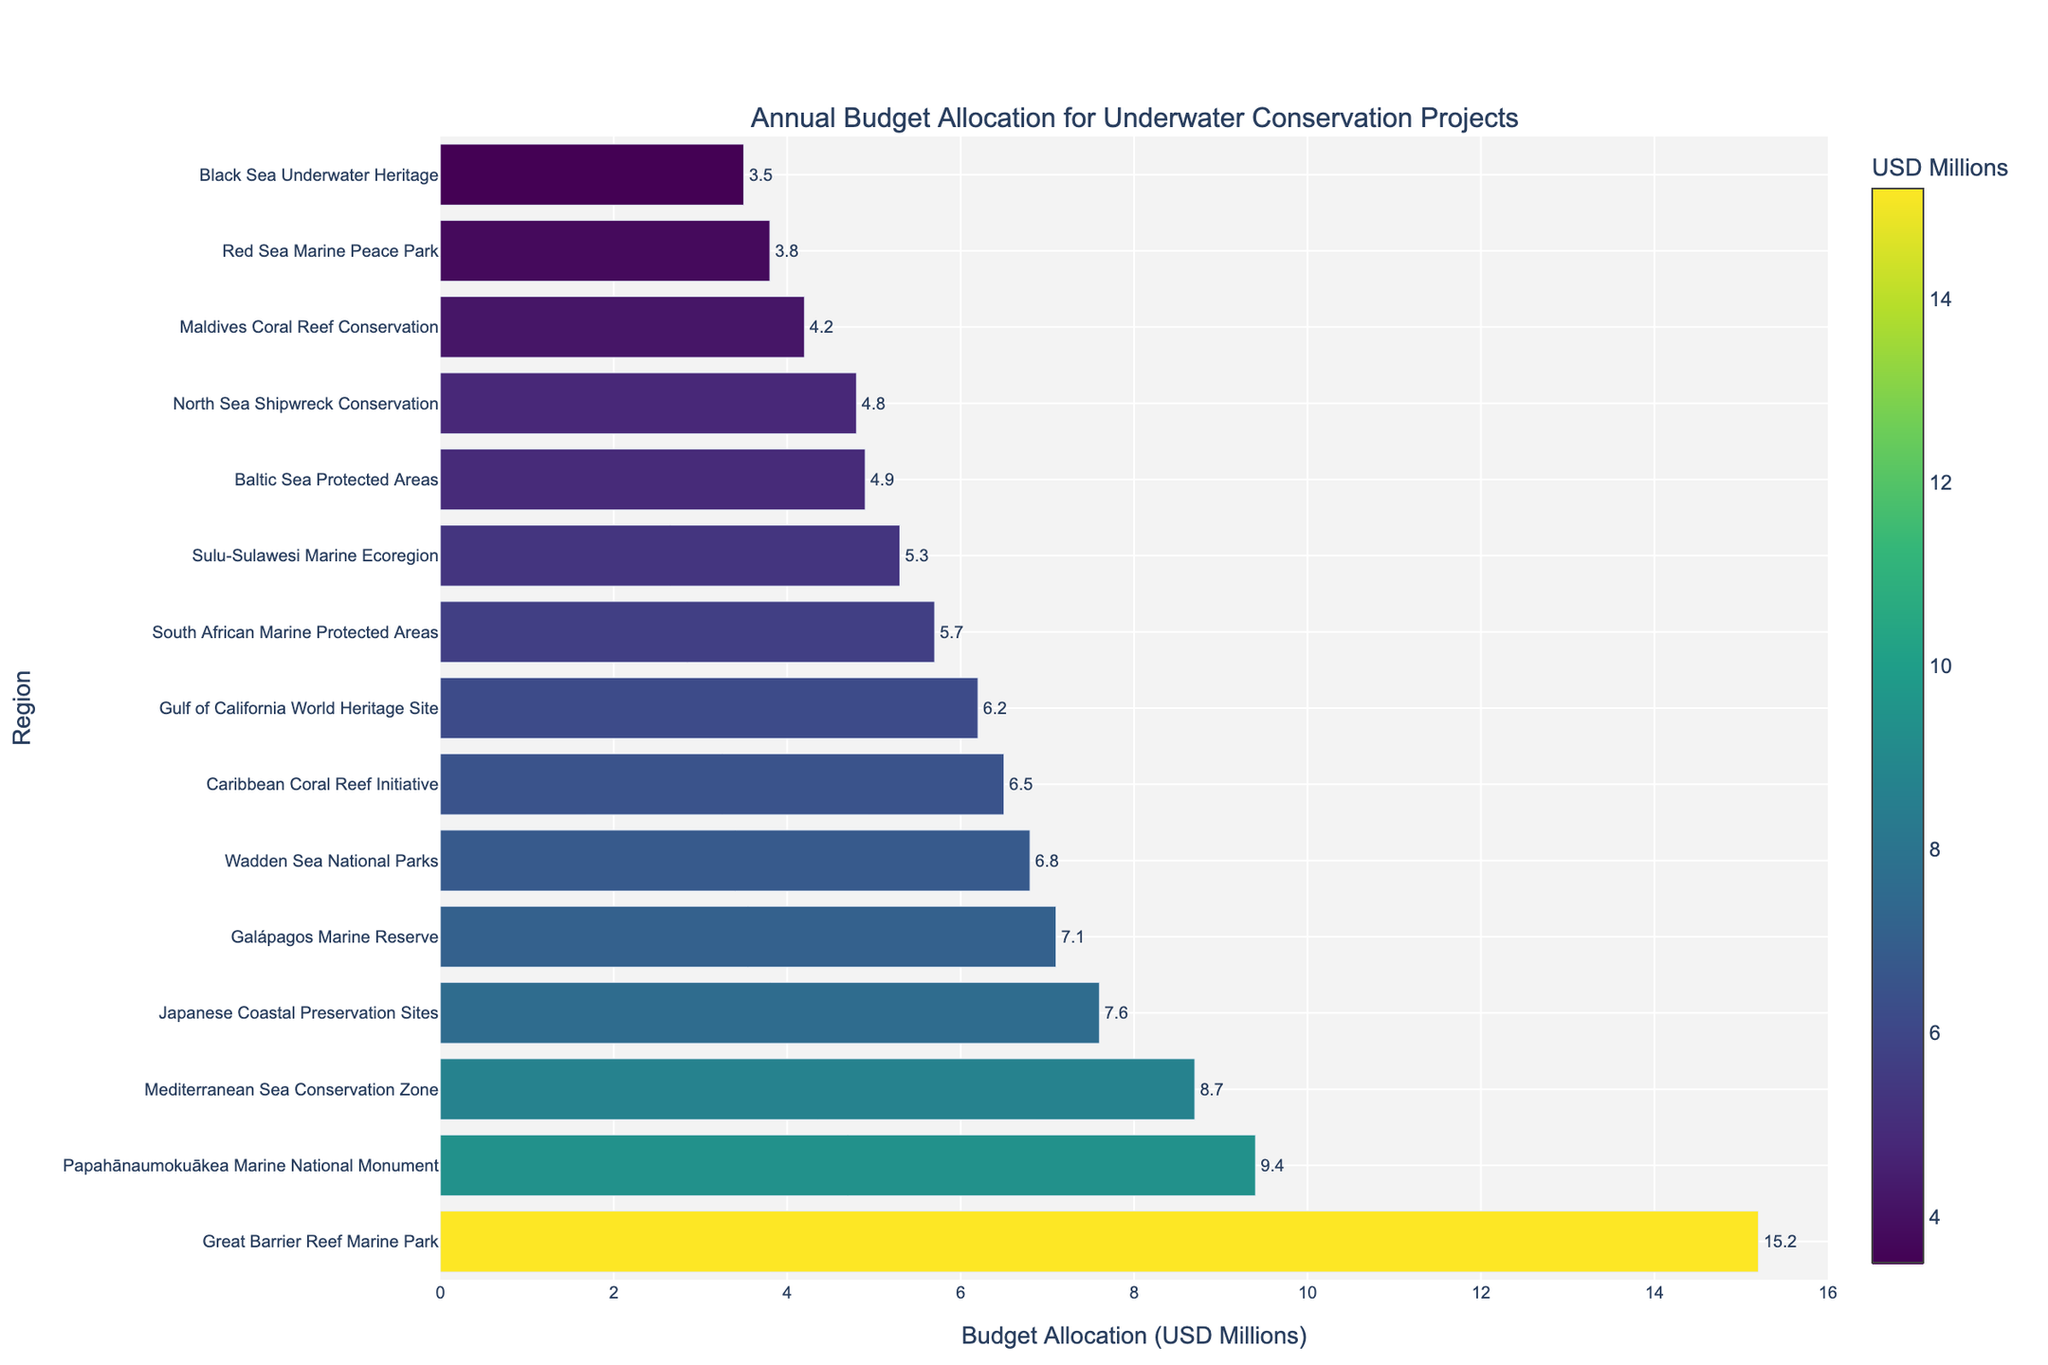Which region has the highest budget allocation for underwater conservation projects? By looking at the bar chart, identify the longest bar representing the region with the largest budget allocation.
Answer: Great Barrier Reef Marine Park Which region has the smallest budget allocation for underwater conservation projects? By examining the chart, identify the shortest bar representing the region with the smallest budget allocation.
Answer: Black Sea Underwater Heritage Add the budget allocations for the Mediterranean Sea Conservation Zone and the Caribbean Coral Reef Initiative. What is the total? First, locate the bars for the Mediterranean Sea Conservation Zone (8.7) and the Caribbean Coral Reef Initiative (6.5). Then, add them together: 8.7 + 6.5 = 15.2.
Answer: 15.2 Which region has a higher budget allocation: Papahānaumokuākea Marine National Monument or Japanese Coastal Preservation Sites? Compare the bars for Papahānaumokuākea Marine National Monument (9.4) and Japanese Coastal Preservation Sites (7.6). The longer bar corresponds to the higher allocation.
Answer: Papahānaumokuākea Marine National Monument Among the regions with budget allocations above 5 million USD, which one has the lowest allocation? First, filter out the regions with budget allocations above 5 million USD. Among these, identify the smallest allocation.
Answer: Wadden Sea National Parks Find the difference in budget allocation between the Galápagos Marine Reserve and Great Barrier Reef Marine Park. Identify the bars for the Galápagos Marine Reserve (7.1) and Great Barrier Reef Marine Park (15.2). Subtract the smaller value from the larger: 15.2 - 7.1 = 8.1.
Answer: 8.1 How many regions have a budget allocation between 4 and 6 million USD? Count the number of bars that fall within the range of 4 to 6 million USD. The regions are Baltic Sea Protected Areas, Maldives Coral Reef Conservation, South African Marine Protected Areas, and North Sea Shipwreck Conservation.
Answer: 4 What's the sum of the budget allocations for the Great Barrier Reef Marine Park, Red Sea Marine Peace Park, and Sulu-Sulawesi Marine Ecoregion? Add the values for the Great Barrier Reef Marine Park (15.2), Red Sea Marine Peace Park (3.8), and Sulu-Sulawesi Marine Ecoregion (5.3): 15.2 + 3.8 + 5.3 = 24.3.
Answer: 24.3 Among the top 5 regions with the highest budget allocation, which one has the median value? First, identify the top 5 regions with the highest budget allocation: Great Barrier Reef Marine Park, Papahānaumokuākea Marine National Monument, Mediterranean Sea Conservation Zone, Japanese Coastal Preservation Sites, and Galápagos Marine Reserve. Then, find the median value, which is the third highest value.
Answer: Japanese Coastal Preservation Sites Out of the regions listed, which two regions have almost the same budget allocation, and what is that allocation? Look for two bars that have nearly identical lengths. The Mediterranean Sea Conservation Zone (8.7) and Papahānaumokuākea Marine National Monument (9.4) are close, but Wadden Sea National Parks (6.8) and Caribbean Coral Reef Initiative (6.5) are even closer. Their allocations are nearly the same.
Answer: Wadden Sea National Parks and Caribbean Coral Reef Initiative; 6.8 and 6.5 respectively 